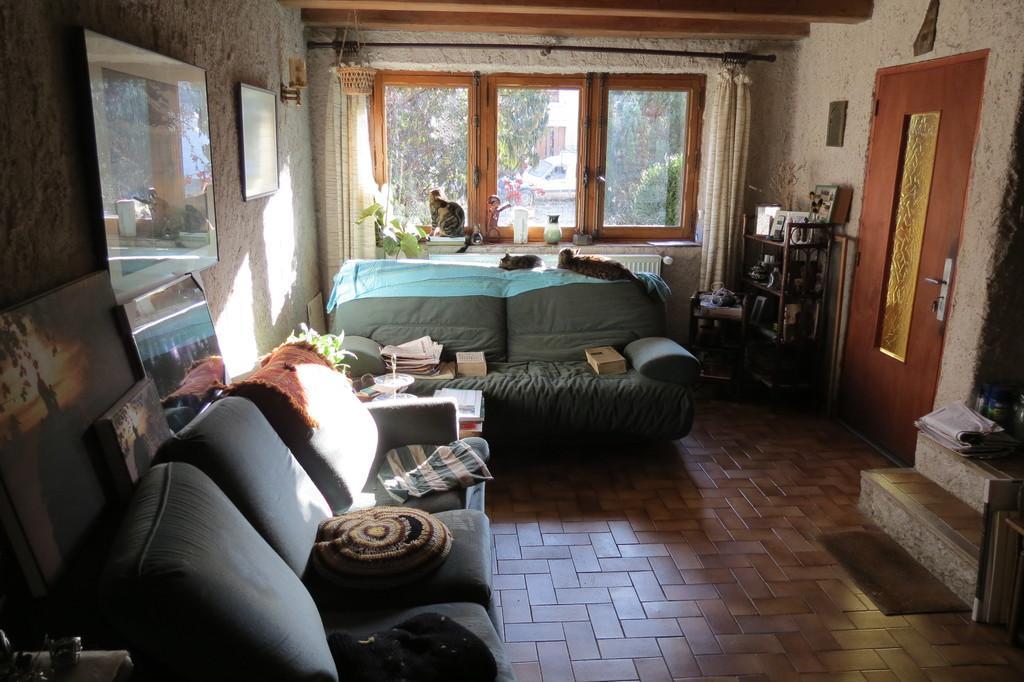Could you give a brief overview of what you see in this image? Here in this picture we can see a sofa and chairs present on the floor and we can also see cushions on it and behind that we can see windows present, through which we can see other buildings and plants and trees and on the wall we can see some portraits present and on the right side we can see a door present and beside that we can see a rack with number of things on it present and in the middle we can see some books and papers present on the sofa. 